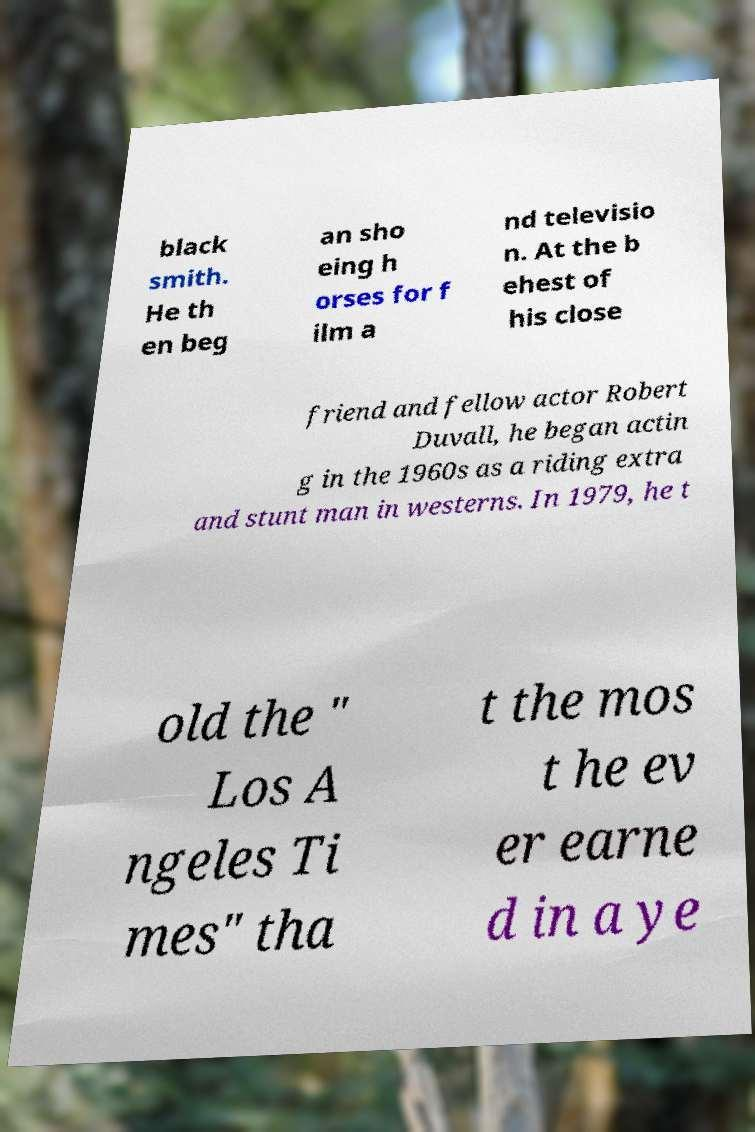Can you accurately transcribe the text from the provided image for me? black smith. He th en beg an sho eing h orses for f ilm a nd televisio n. At the b ehest of his close friend and fellow actor Robert Duvall, he began actin g in the 1960s as a riding extra and stunt man in westerns. In 1979, he t old the " Los A ngeles Ti mes" tha t the mos t he ev er earne d in a ye 